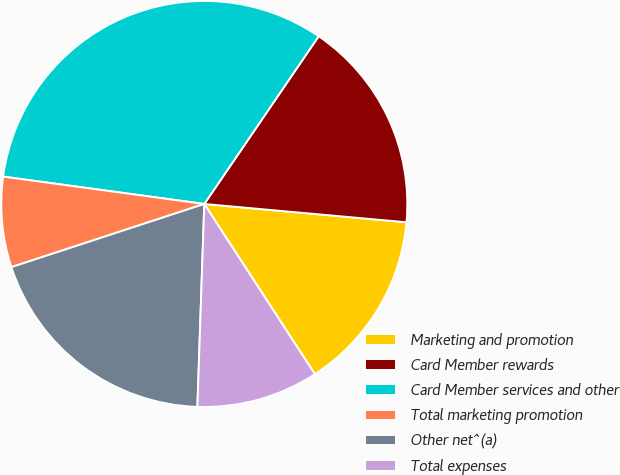Convert chart. <chart><loc_0><loc_0><loc_500><loc_500><pie_chart><fcel>Marketing and promotion<fcel>Card Member rewards<fcel>Card Member services and other<fcel>Total marketing promotion<fcel>Other net^(a)<fcel>Total expenses<nl><fcel>14.39%<fcel>16.91%<fcel>32.37%<fcel>7.19%<fcel>19.42%<fcel>9.71%<nl></chart> 